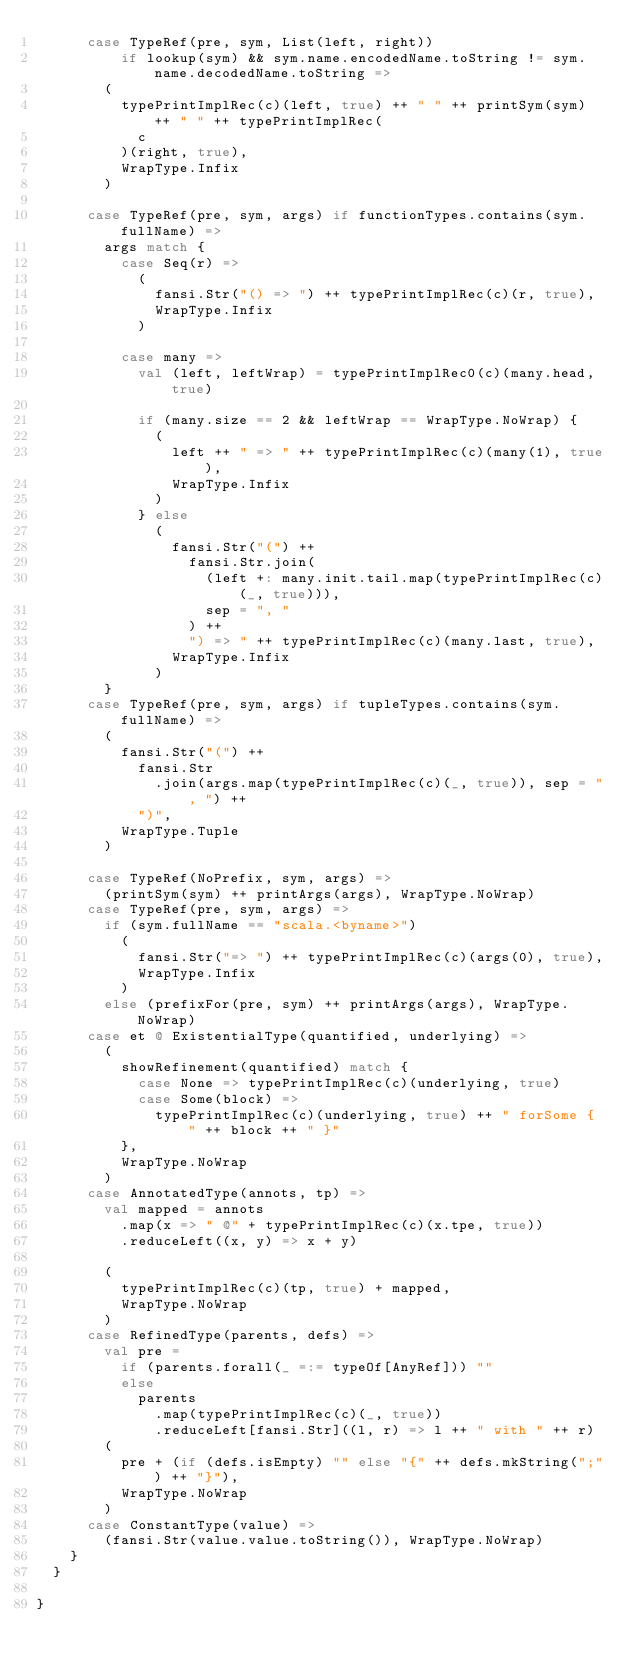Convert code to text. <code><loc_0><loc_0><loc_500><loc_500><_Scala_>      case TypeRef(pre, sym, List(left, right))
          if lookup(sym) && sym.name.encodedName.toString != sym.name.decodedName.toString =>
        (
          typePrintImplRec(c)(left, true) ++ " " ++ printSym(sym) ++ " " ++ typePrintImplRec(
            c
          )(right, true),
          WrapType.Infix
        )

      case TypeRef(pre, sym, args) if functionTypes.contains(sym.fullName) =>
        args match {
          case Seq(r) =>
            (
              fansi.Str("() => ") ++ typePrintImplRec(c)(r, true),
              WrapType.Infix
            )

          case many =>
            val (left, leftWrap) = typePrintImplRec0(c)(many.head, true)

            if (many.size == 2 && leftWrap == WrapType.NoWrap) {
              (
                left ++ " => " ++ typePrintImplRec(c)(many(1), true),
                WrapType.Infix
              )
            } else
              (
                fansi.Str("(") ++
                  fansi.Str.join(
                    (left +: many.init.tail.map(typePrintImplRec(c)(_, true))),
                    sep = ", "
                  ) ++
                  ") => " ++ typePrintImplRec(c)(many.last, true),
                WrapType.Infix
              )
        }
      case TypeRef(pre, sym, args) if tupleTypes.contains(sym.fullName) =>
        (
          fansi.Str("(") ++
            fansi.Str
              .join(args.map(typePrintImplRec(c)(_, true)), sep = ", ") ++
            ")",
          WrapType.Tuple
        )

      case TypeRef(NoPrefix, sym, args) =>
        (printSym(sym) ++ printArgs(args), WrapType.NoWrap)
      case TypeRef(pre, sym, args) =>
        if (sym.fullName == "scala.<byname>")
          (
            fansi.Str("=> ") ++ typePrintImplRec(c)(args(0), true),
            WrapType.Infix
          )
        else (prefixFor(pre, sym) ++ printArgs(args), WrapType.NoWrap)
      case et @ ExistentialType(quantified, underlying) =>
        (
          showRefinement(quantified) match {
            case None => typePrintImplRec(c)(underlying, true)
            case Some(block) =>
              typePrintImplRec(c)(underlying, true) ++ " forSome { " ++ block ++ " }"
          },
          WrapType.NoWrap
        )
      case AnnotatedType(annots, tp) =>
        val mapped = annots
          .map(x => " @" + typePrintImplRec(c)(x.tpe, true))
          .reduceLeft((x, y) => x + y)

        (
          typePrintImplRec(c)(tp, true) + mapped,
          WrapType.NoWrap
        )
      case RefinedType(parents, defs) =>
        val pre =
          if (parents.forall(_ =:= typeOf[AnyRef])) ""
          else
            parents
              .map(typePrintImplRec(c)(_, true))
              .reduceLeft[fansi.Str]((l, r) => l ++ " with " ++ r)
        (
          pre + (if (defs.isEmpty) "" else "{" ++ defs.mkString(";") ++ "}"),
          WrapType.NoWrap
        )
      case ConstantType(value) =>
        (fansi.Str(value.value.toString()), WrapType.NoWrap)
    }
  }

}
</code> 